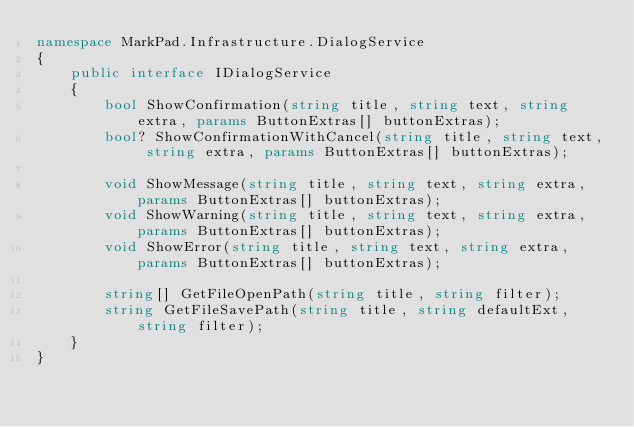Convert code to text. <code><loc_0><loc_0><loc_500><loc_500><_C#_>namespace MarkPad.Infrastructure.DialogService
{
    public interface IDialogService
    {
        bool ShowConfirmation(string title, string text, string extra, params ButtonExtras[] buttonExtras);
        bool? ShowConfirmationWithCancel(string title, string text, string extra, params ButtonExtras[] buttonExtras);

        void ShowMessage(string title, string text, string extra, params ButtonExtras[] buttonExtras);
        void ShowWarning(string title, string text, string extra, params ButtonExtras[] buttonExtras);
        void ShowError(string title, string text, string extra, params ButtonExtras[] buttonExtras);

        string[] GetFileOpenPath(string title, string filter);
        string GetFileSavePath(string title, string defaultExt, string filter);
    }
}
</code> 